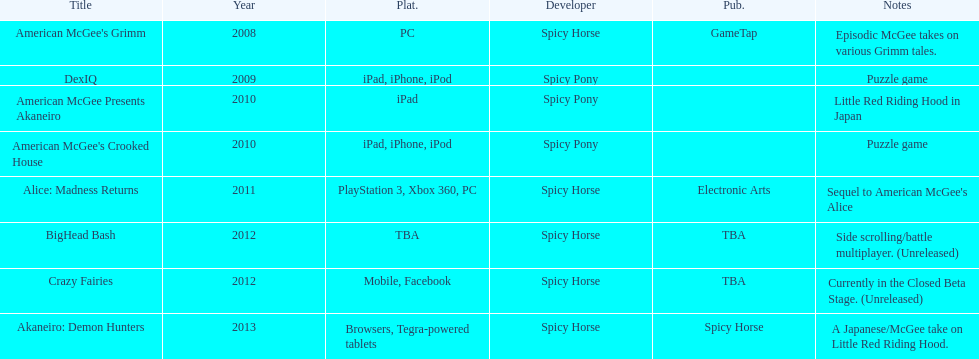According to the table, what is the last title that spicy horse produced? Akaneiro: Demon Hunters. 